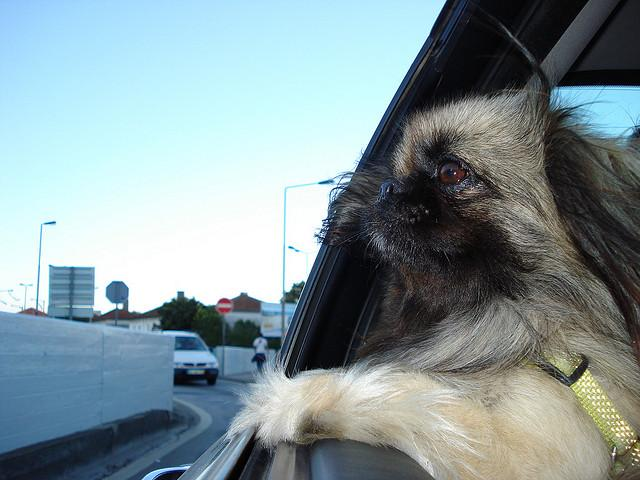What kind of pet is looking out the window? Please explain your reasoning. cat. It is larger than a cat and is a domesticated furry pet 